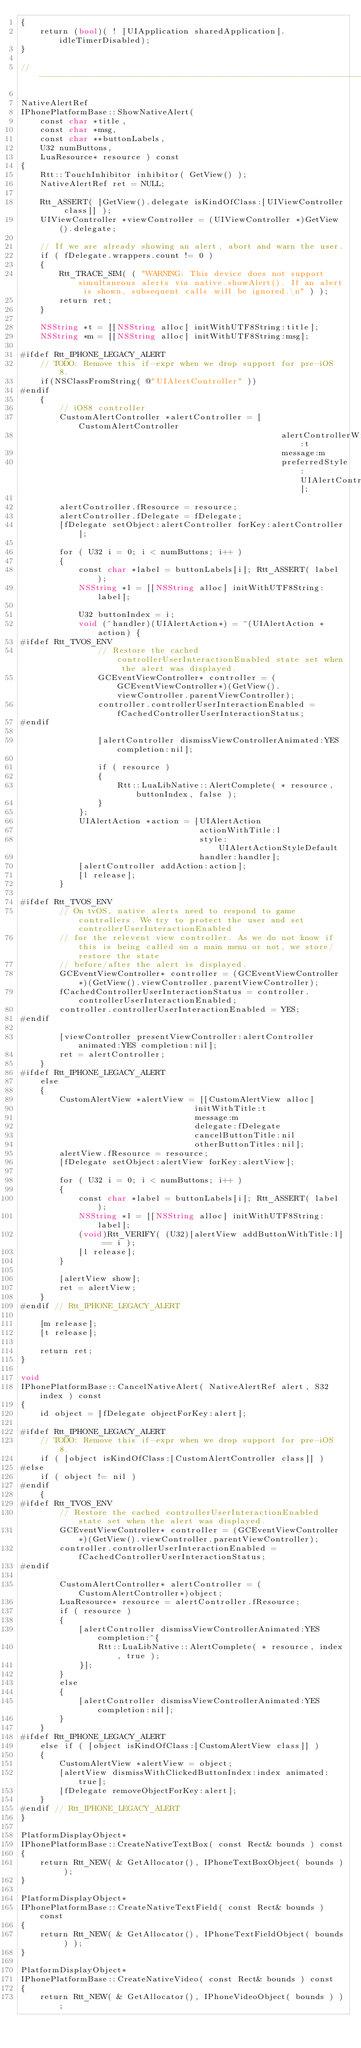Convert code to text. <code><loc_0><loc_0><loc_500><loc_500><_ObjectiveC_>{
	return (bool)( ! [UIApplication sharedApplication].idleTimerDisabled);
}

// ----------------------------------------------------------------------------

NativeAlertRef
IPhonePlatformBase::ShowNativeAlert(
	const char *title,
	const char *msg,
	const char **buttonLabels,
	U32 numButtons,
	LuaResource* resource ) const
{
	Rtt::TouchInhibitor inhibitor( GetView() );
	NativeAlertRef ret = NULL;
	
	Rtt_ASSERT( [GetView().delegate isKindOfClass:[UIViewController class]] );
	UIViewController *viewController = (UIViewController *)GetView().delegate;
	
	// If we are already showing an alert, abort and warn the user.
	if ( fDelegate.wrappers.count != 0 )
	{
		Rtt_TRACE_SIM( ( "WARNING: This device does not support simultaneous alerts via native.showAlert(). If an alert is shown, subsequent calls will be ignored.\n" ) );
		return ret;
	}

	NSString *t = [[NSString alloc] initWithUTF8String:title];
	NSString *m = [[NSString alloc] initWithUTF8String:msg];
	
#ifdef Rtt_IPHONE_LEGACY_ALERT
	// TODO: Remove this if-expr when we drop support for pre-iOS 8.
	if(NSClassFromString( @"UIAlertController" ))
#endif
	{
		// iOS8 controller
		CustomAlertController *alertController = [CustomAlertController
													  alertControllerWithTitle:t
													  message:m
													  preferredStyle:UIAlertControllerStyleAlert];
		
		alertController.fResource = resource;
		alertController.fDelegate = fDelegate;
		[fDelegate setObject:alertController forKey:alertController];
		
		for ( U32 i = 0; i < numButtons; i++ )
		{
			const char *label = buttonLabels[i]; Rtt_ASSERT( label );
			NSString *l = [[NSString alloc] initWithUTF8String:label];
			
			U32 buttonIndex = i;
			void (^handler)(UIAlertAction*) = ^(UIAlertAction *action) {
#ifdef Rtt_TVOS_ENV
				// Restore the cached controllerUserInteractionEnabled state set when the alert was displayed.
				GCEventViewController* controller = (GCEventViewController*)(GetView().viewController.parentViewController);
				controller.controllerUserInteractionEnabled = fCachedControllerUserInteractionStatus;
#endif
				
				[alertController dismissViewControllerAnimated:YES completion:nil];
				
				if ( resource )
				{
					Rtt::LuaLibNative::AlertComplete( * resource, buttonIndex, false );
				}
			};
			UIAlertAction *action = [UIAlertAction
									 actionWithTitle:l
									 style:UIAlertActionStyleDefault
									 handler:handler];
			[alertController addAction:action];
			[l release];
		}
		
#ifdef Rtt_TVOS_ENV
		// On tvOS, native alerts need to respond to game controllers. We try to protect the user and set controllerUserInteractionEnabled
		// for the relevent view controller. As we do not know if this is being called on a main menu or not, we store/restore the state
		// before/after the alert is displayed.
		GCEventViewController* controller = (GCEventViewController*)(GetView().viewController.parentViewController);
		fCachedControllerUserInteractionStatus = controller.controllerUserInteractionEnabled;
		controller.controllerUserInteractionEnabled = YES;
#endif
		
		[viewController presentViewController:alertController animated:YES completion:nil];
		ret = alertController;
	}
#ifdef Rtt_IPHONE_LEGACY_ALERT
	else
	{
		CustomAlertView *alertView = [[CustomAlertView alloc]
									initWithTitle:t
									message:m
									delegate:fDelegate
									cancelButtonTitle:nil
									otherButtonTitles:nil];
		alertView.fResource = resource;
		[fDelegate setObject:alertView forKey:alertView];

		for ( U32 i = 0; i < numButtons; i++ )
		{
			const char *label = buttonLabels[i]; Rtt_ASSERT( label );
			NSString *l = [[NSString alloc] initWithUTF8String:label];
			(void)Rtt_VERIFY( (U32)[alertView addButtonWithTitle:l] == i );
			[l release];
		}

		[alertView show];
		ret = alertView;
	}
#endif // Rtt_IPHONE_LEGACY_ALERT
	
	[m release];
	[t release];

	return ret;
}

void
IPhonePlatformBase::CancelNativeAlert( NativeAlertRef alert, S32 index ) const
{
	id object = [fDelegate objectForKey:alert];
	
#ifdef Rtt_IPHONE_LEGACY_ALERT
	// TODO: Remove this if-expr when we drop support for pre-iOS 8.
	if ( [object isKindOfClass:[CustomAlertController class]] )
#else
	if ( object != nil )
#endif
	{
#ifdef Rtt_TVOS_ENV
		// Restore the cached controllerUserInteractionEnabled state set when the alert was displayed.
		GCEventViewController* controller = (GCEventViewController*)(GetView().viewController.parentViewController);
		controller.controllerUserInteractionEnabled = fCachedControllerUserInteractionStatus;
#endif
		
		CustomAlertController* alertController = (CustomAlertController*)object;
		LuaResource* resource = alertController.fResource;
		if ( resource )
		{
			[alertController dismissViewControllerAnimated:YES completion:^{
				Rtt::LuaLibNative::AlertComplete( * resource, index, true );
			}];
		}
		else
		{
			[alertController dismissViewControllerAnimated:YES completion:nil];
		}
	}
#ifdef Rtt_IPHONE_LEGACY_ALERT
	else if ( [object isKindOfClass:[CustomAlertView class]] )
	{
		CustomAlertView *alertView = object;
		[alertView dismissWithClickedButtonIndex:index animated:true];
		[fDelegate removeObjectForKey:alert];
	}
#endif // Rtt_IPHONE_LEGACY_ALERT
}

PlatformDisplayObject*
IPhonePlatformBase::CreateNativeTextBox( const Rect& bounds ) const
{
	return Rtt_NEW( & GetAllocator(), IPhoneTextBoxObject( bounds ) );
}

PlatformDisplayObject*
IPhonePlatformBase::CreateNativeTextField( const Rect& bounds ) const
{
	return Rtt_NEW( & GetAllocator(), IPhoneTextFieldObject( bounds ) );
}

PlatformDisplayObject*
IPhonePlatformBase::CreateNativeVideo( const Rect& bounds ) const
{
	return Rtt_NEW( & GetAllocator(), IPhoneVideoObject( bounds ) );</code> 